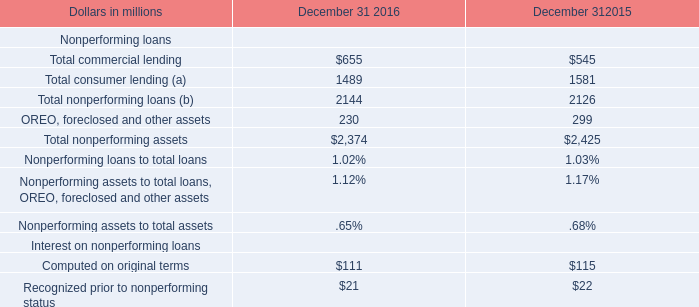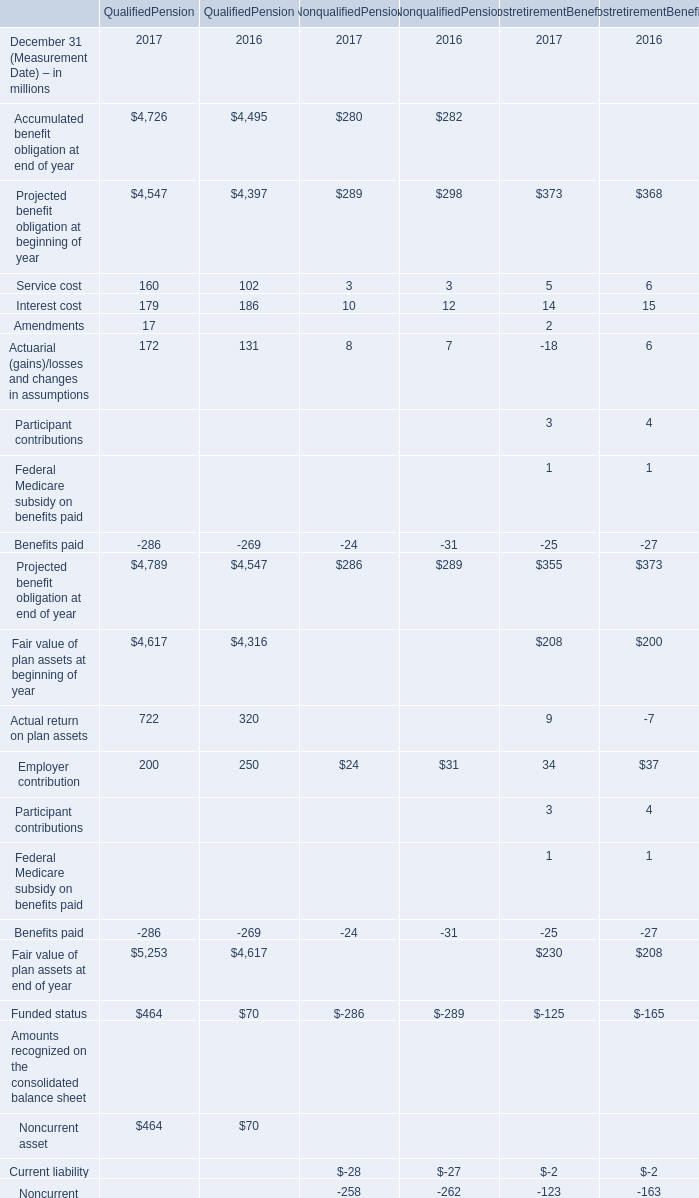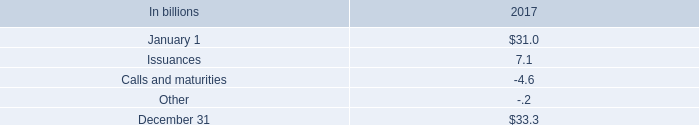What is the growing rate Current liability in the years with the least Projected benefit obligation at end of year for non qualified pension? (in %) 
Computations: ((-28 + 27) / -27)
Answer: 0.03704. 